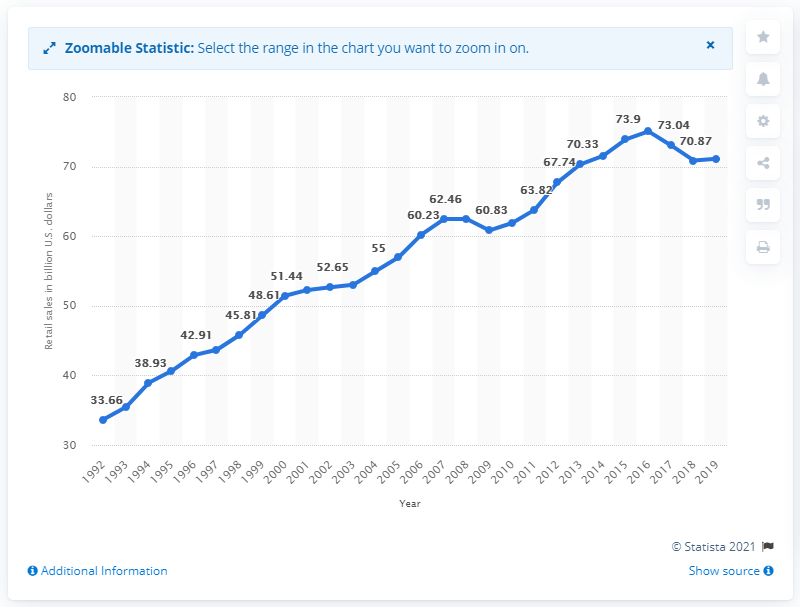Indicate a few pertinent items in this graphic. In 2019, the total sales of sporting goods, hobby, and musical instrument stores in the United States amounted to $70.33 billion. 